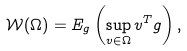<formula> <loc_0><loc_0><loc_500><loc_500>\mathcal { W } ( \Omega ) = E _ { g } \left ( \sup _ { v \in \Omega } v ^ { T } g \right ) ,</formula> 